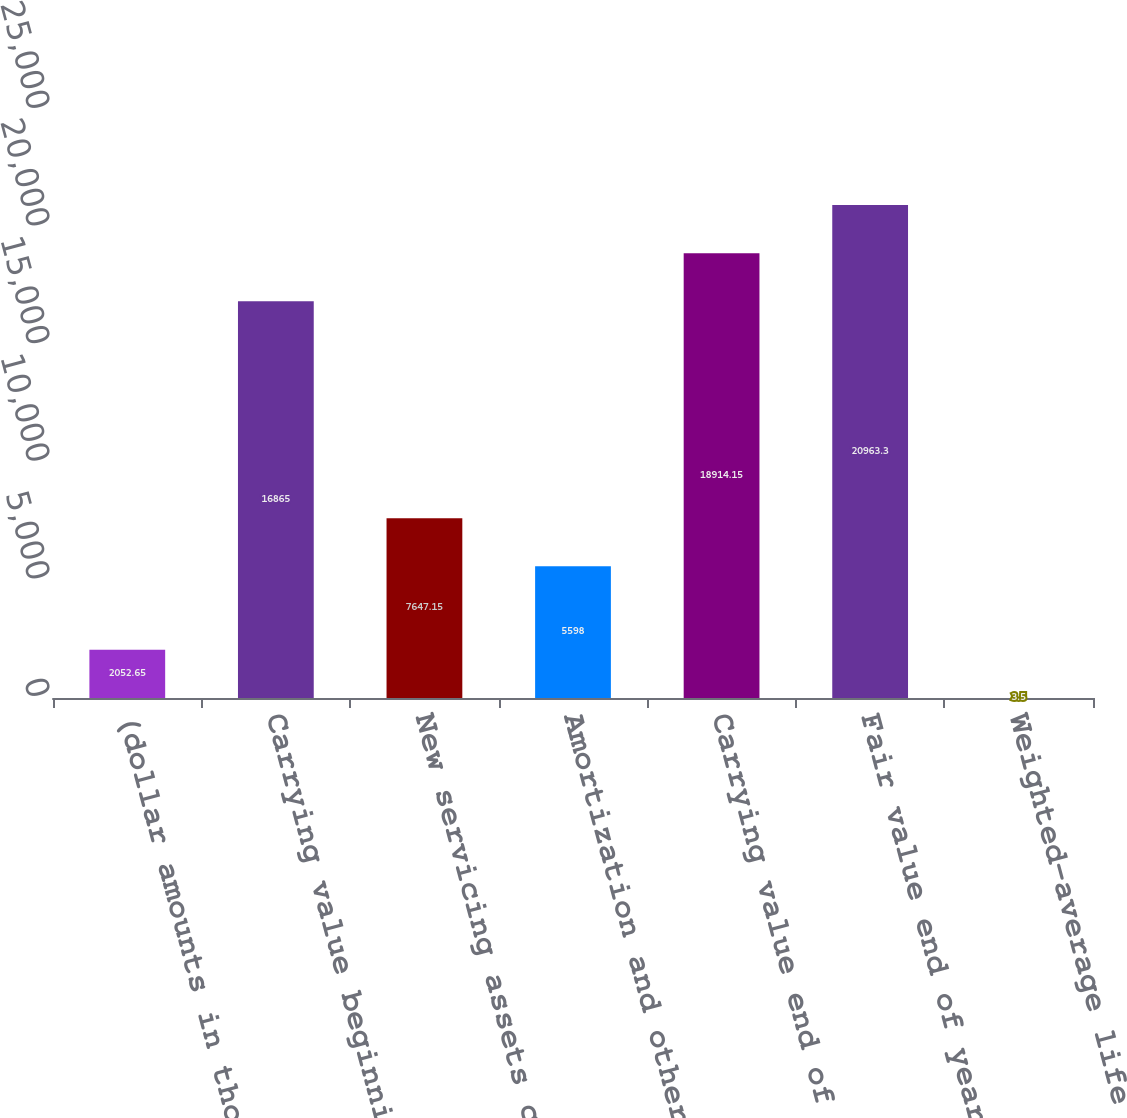<chart> <loc_0><loc_0><loc_500><loc_500><bar_chart><fcel>(dollar amounts in thousands)<fcel>Carrying value beginning of<fcel>New servicing assets created<fcel>Amortization and other<fcel>Carrying value end of year<fcel>Fair value end of year<fcel>Weighted-average life (years)<nl><fcel>2052.65<fcel>16865<fcel>7647.15<fcel>5598<fcel>18914.2<fcel>20963.3<fcel>3.5<nl></chart> 